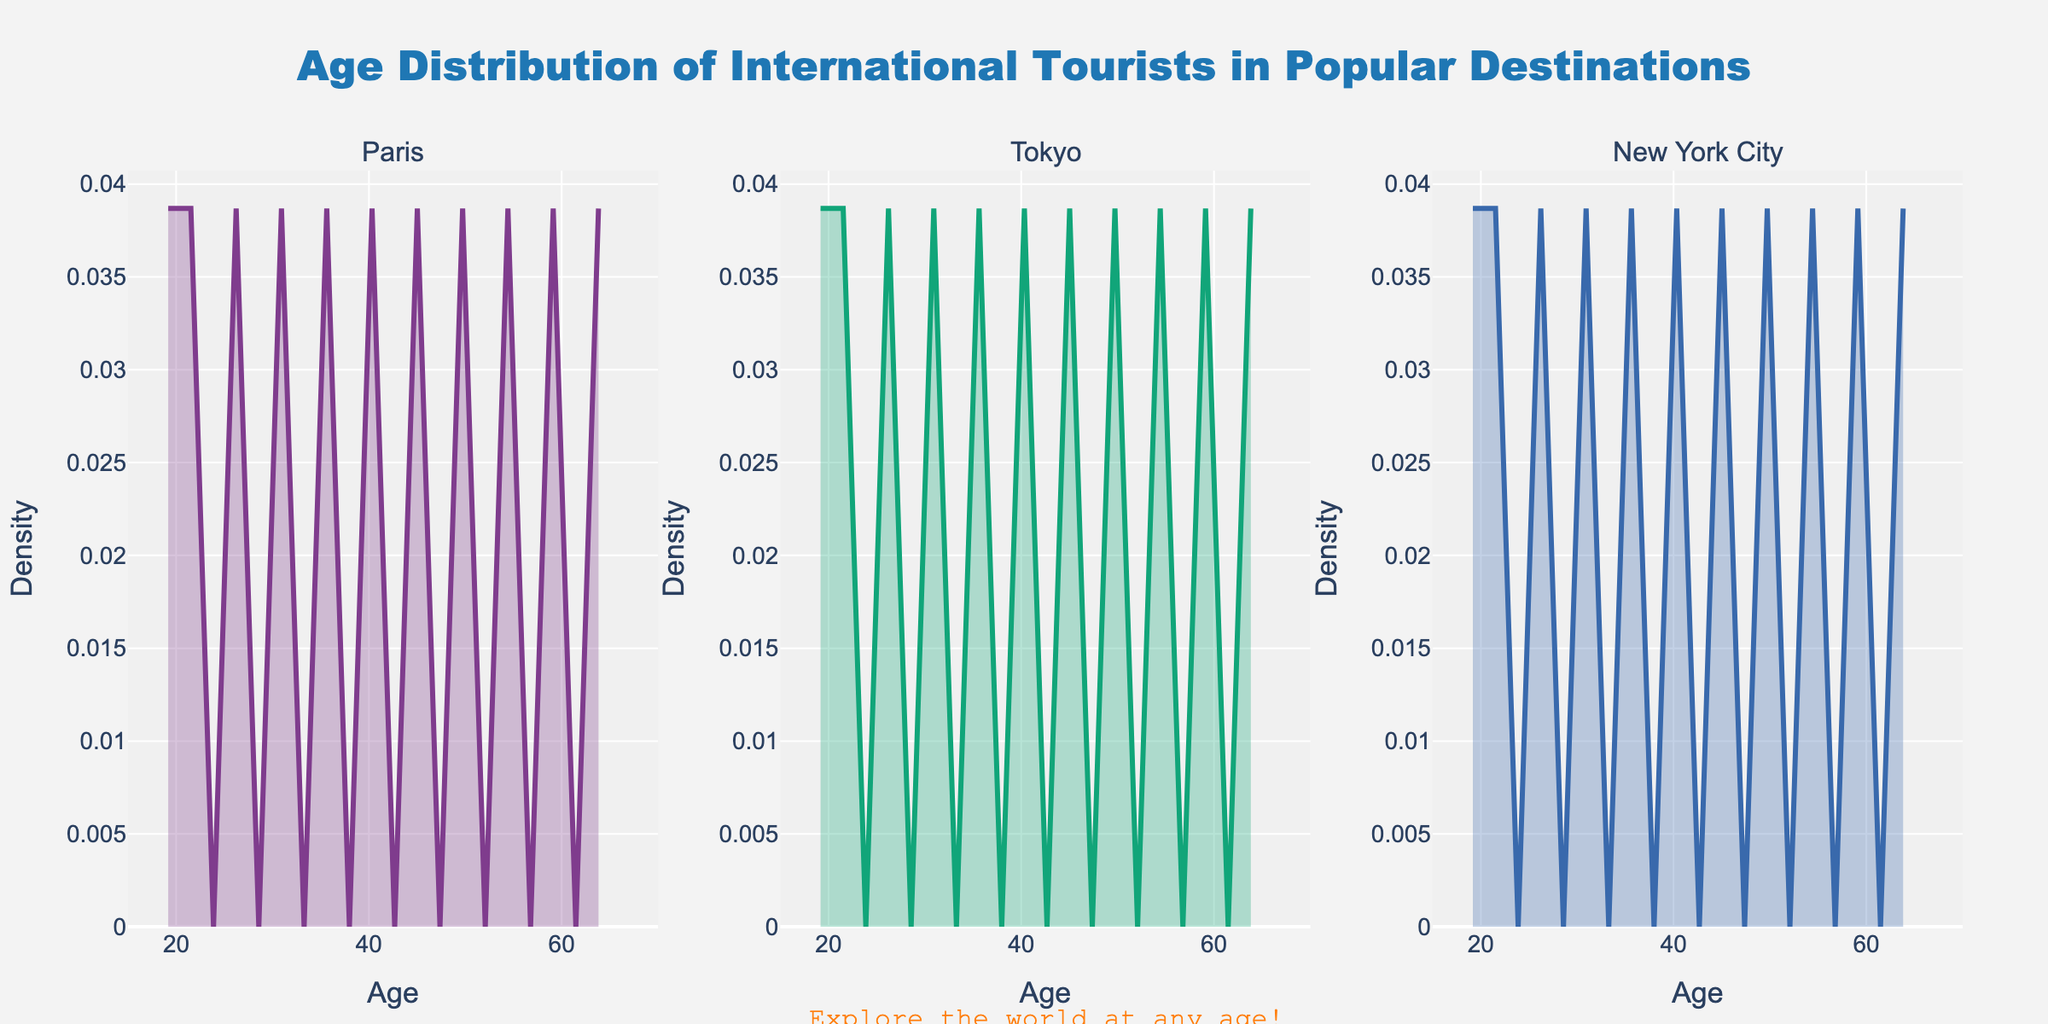What is the title of the figure? The title is written at the top center of the figure.
Answer: "Age Distribution of International Tourists in Popular Destinations" Which age group has the peak density for Paris? By observing the Paris subplot, the peak density occurs around the x-axis value corresponding to the highest point of the curve.
Answer: 30 How does the density of tourists aged 40 compare between Paris and New York City? Compare the y-value at x=40 for both the Paris and New York City subplots. The y-value is higher for Paris than for New York City.
Answer: Higher in Paris At what ages do the curves for Tokyo and New York City seem to be similar? Look at the overlapping region of the curves in the Tokyo and New York City subplots. They seem similar around age 40 to 45.
Answer: 40-45 What age group has the lowest density of tourists in Tokyo? Observe the y-values across the x-axis in the Tokyo subplot to find the minimum.
Answer: 65 What general trend do you notice about the density plots for all three destinations? Identify the common shape or direction of the curves in all three subplots. All three destinations show a decreasing trend in tourist density as age increases beyond 30.
Answer: Decreasing trend with age Around what age do the densities for Paris and Tokyo diverge most? Find the x-axis value where the separation between the curves for Paris and Tokyo is the largest.
Answer: 26 Which destination has the highest peak density and at what age does it occur? Identify the subplot with the highest peak and note the corresponding x-axis value.
Answer: New York City, Age 30 How does the density distribution of tourists aged 55 in Paris compare to that in Tokyo? Compare the height (y-value) of the curve at age 55 between the Paris and Tokyo subplots. Paris has a higher density for tourists aged 55 compared to Tokyo.
Answer: Higher in Paris 